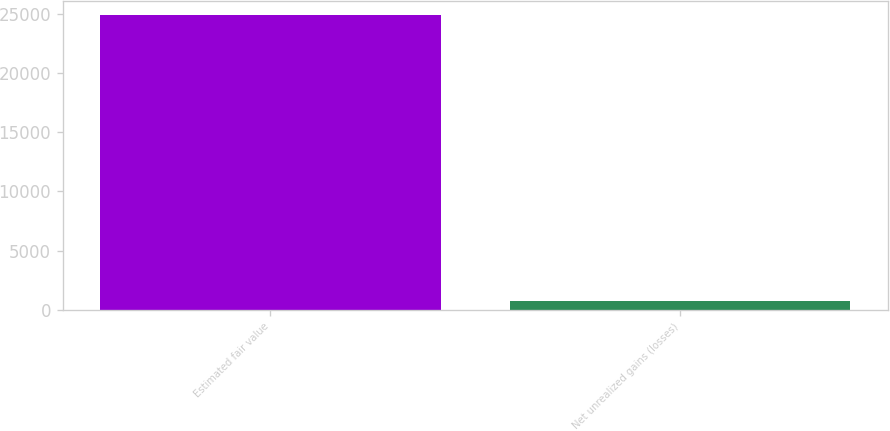<chart> <loc_0><loc_0><loc_500><loc_500><bar_chart><fcel>Estimated fair value<fcel>Net unrealized gains (losses)<nl><fcel>24870<fcel>696<nl></chart> 